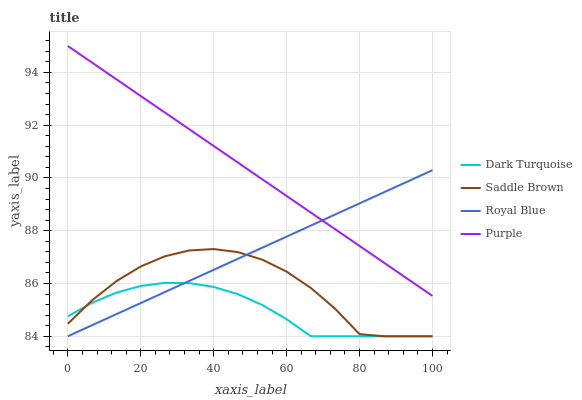Does Dark Turquoise have the minimum area under the curve?
Answer yes or no. Yes. Does Purple have the maximum area under the curve?
Answer yes or no. Yes. Does Saddle Brown have the minimum area under the curve?
Answer yes or no. No. Does Saddle Brown have the maximum area under the curve?
Answer yes or no. No. Is Purple the smoothest?
Answer yes or no. Yes. Is Saddle Brown the roughest?
Answer yes or no. Yes. Is Dark Turquoise the smoothest?
Answer yes or no. No. Is Dark Turquoise the roughest?
Answer yes or no. No. Does Dark Turquoise have the lowest value?
Answer yes or no. Yes. Does Purple have the highest value?
Answer yes or no. Yes. Does Saddle Brown have the highest value?
Answer yes or no. No. Is Dark Turquoise less than Purple?
Answer yes or no. Yes. Is Purple greater than Saddle Brown?
Answer yes or no. Yes. Does Saddle Brown intersect Dark Turquoise?
Answer yes or no. Yes. Is Saddle Brown less than Dark Turquoise?
Answer yes or no. No. Is Saddle Brown greater than Dark Turquoise?
Answer yes or no. No. Does Dark Turquoise intersect Purple?
Answer yes or no. No. 